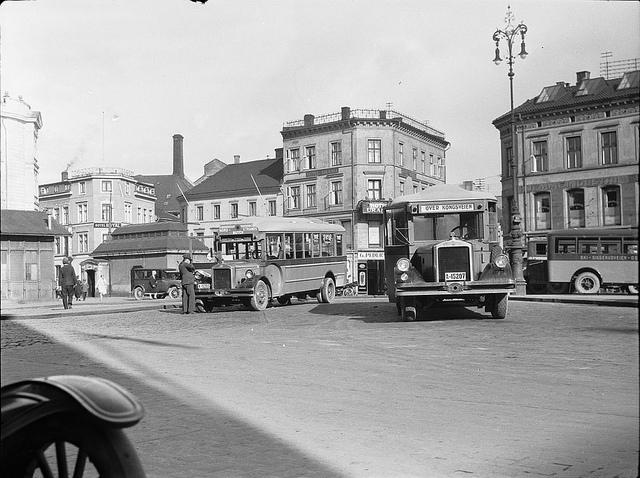Why might we assume this photo was taken before 1999?
Keep it brief. Black and white. How old is this picture?
Be succinct. 60 years. How can you tell this photo is not from present day?
Write a very short answer. Vehicles. Is this a school bus?
Give a very brief answer. Yes. What type of truck is on the right side of the street?
Give a very brief answer. Bus. Is this a colored picture?
Quick response, please. No. Is the triangle shaped building an herb store?
Quick response, please. No. 